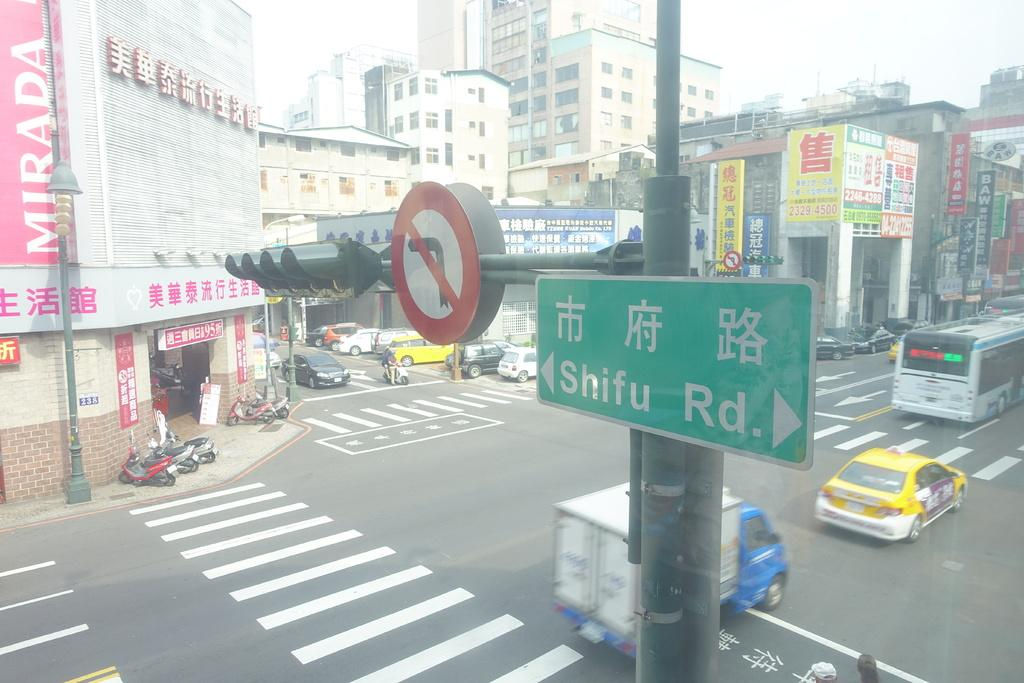<image>
Present a compact description of the photo's key features. Cars pass through an intersection at Shifu Road. 